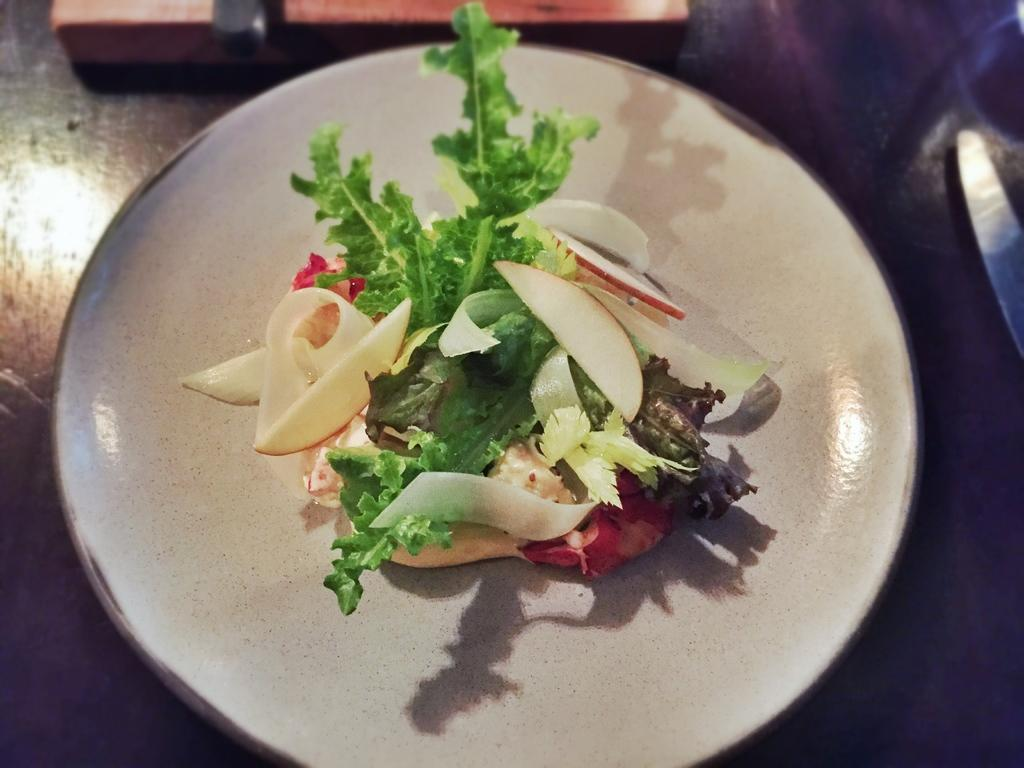What is on the plate that is visible in the image? The plate contains salad. What types of ingredients can be found in the salad? There are leaves and fruits in the salad. What type of celery can be seen in the image? There is no celery present in the image. What kind of test is being conducted on the plate in the image? There is no test being conducted in the image; it is a plate of salad with leaves and fruits. 